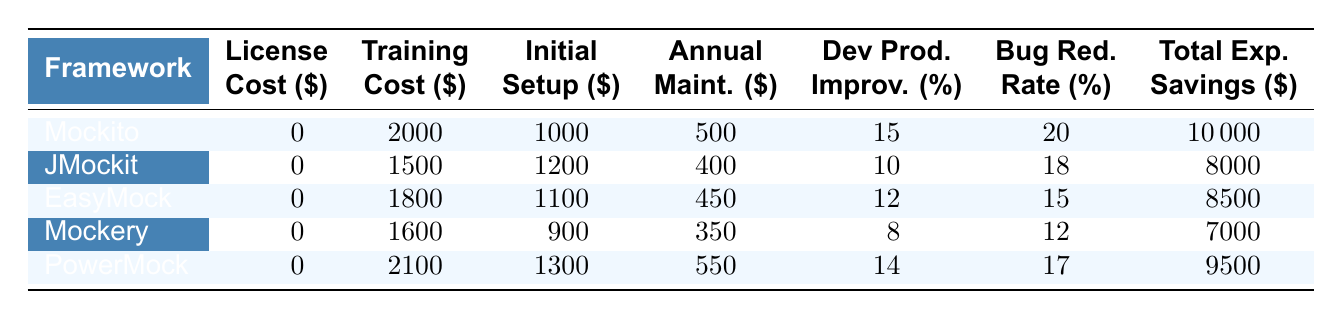What is the total annual cost for using Mockito? To calculate the total annual cost for using Mockito, we need to add the training cost, initial setup cost, and the annual maintenance cost. The training cost is 2000, initial setup cost is 1000, and annual maintenance cost is 500. Therefore, the total annual cost is 2000 + 1000 + 500 = 3500.
Answer: 3500 Which framework has the highest developer productivity improvement? By reviewing the Developer Productivity Improvement column, we see that Mockito has the highest value at 15 percent, compared to the other frameworks.
Answer: Mockito What is the average bug reduction rate for all the frameworks? To find the average bug reduction rate, we add up the bug reduction rates for all frameworks: (20 + 18 + 15 + 12 + 17) = 82. There are 5 frameworks, so we divide the total by 5. Hence, the average is 82 / 5 = 16.4.
Answer: 16.4 Does EasyMock have a higher training cost than JMockit? Checking the Training Cost column, EasyMock has a training cost of 1800 while JMockit has a training cost of 1500. Since 1800 > 1500, we can confirm that EasyMock does indeed have a higher training cost.
Answer: Yes What is the total expected savings for PowerMock compared to Mockery? The Total Expected Savings for PowerMock is 9500 and for Mockery is 7000. To find the difference, we subtract: 9500 - 7000 = 2500.
Answer: 2500 Which framework offers the lowest total expected savings and what is that value? In the Total Expected Savings column, we see that Mockery has the lowest value at 7000.
Answer: Mockery, 7000 If we consider the total costs (training, setup, and maintenance) for each framework, which framework has the lowest total cost? We calculate the total costs for each framework: Mockito (3500), JMockit (3100), EasyMock (2900), Mockery (2900), PowerMock (3150). The frameworks with the lowest total cost are EasyMock and Mockery at 2900.
Answer: EasyMock, Mockery, 2900 How much more is the initial setup cost for PowerMock compared to Mockito? The Initial Setup Cost for PowerMock is 1300, and for Mockito it's 1000. The difference is 1300 - 1000 = 300.
Answer: 300 Is the developer productivity improvement for JMockit less than 12 percent? The Developer Productivity Improvement for JMockit is 10 percent, which is indeed less than 12 percent. Therefore, the answer is true.
Answer: Yes 